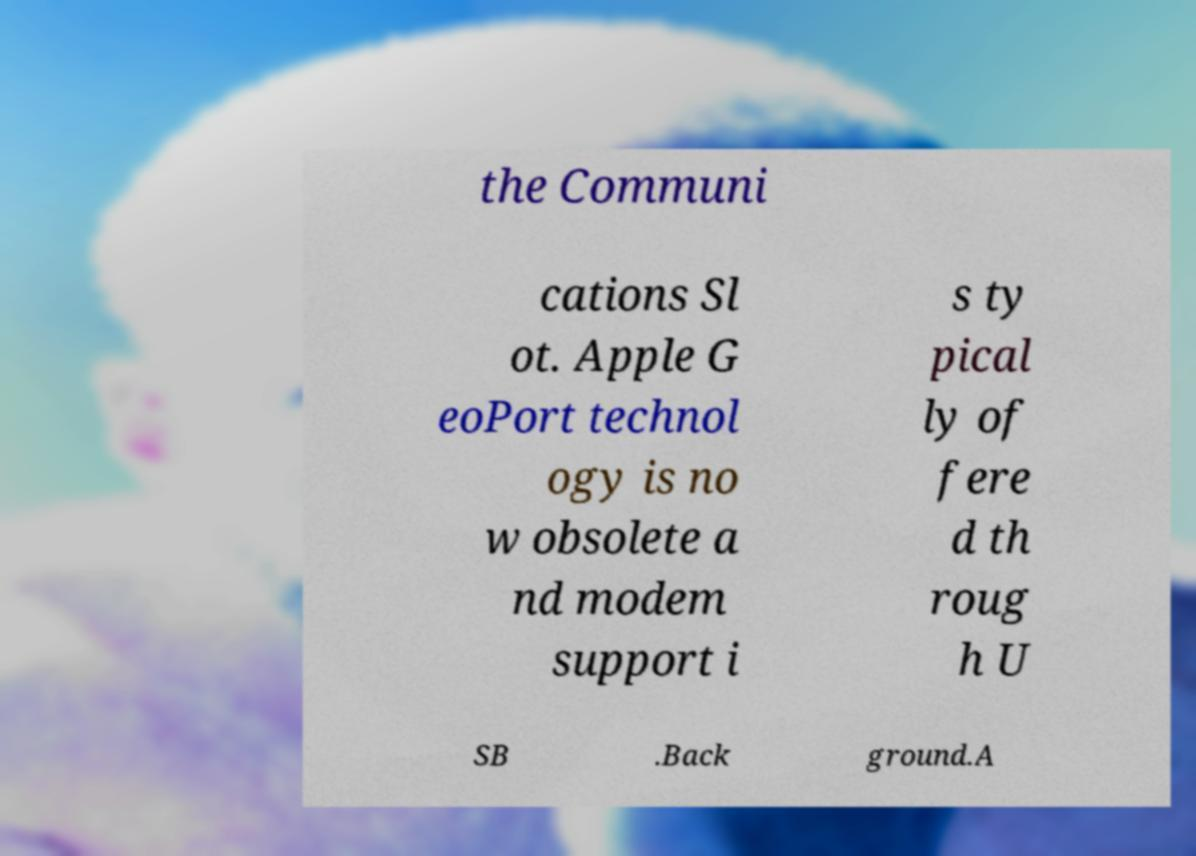For documentation purposes, I need the text within this image transcribed. Could you provide that? the Communi cations Sl ot. Apple G eoPort technol ogy is no w obsolete a nd modem support i s ty pical ly of fere d th roug h U SB .Back ground.A 